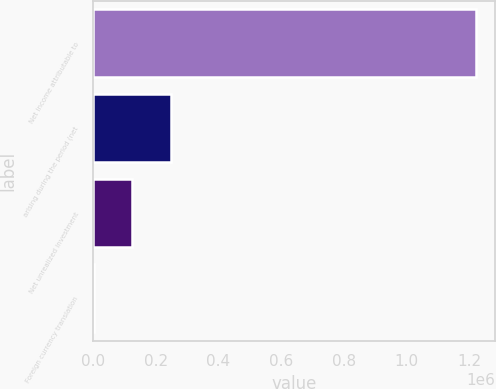Convert chart to OTSL. <chart><loc_0><loc_0><loc_500><loc_500><bar_chart><fcel>Net income attributable to<fcel>arising during the period (net<fcel>Net unrealized investment<fcel>Foreign currency translation<nl><fcel>1.22057e+06<fcel>247741<fcel>126013<fcel>3288<nl></chart> 